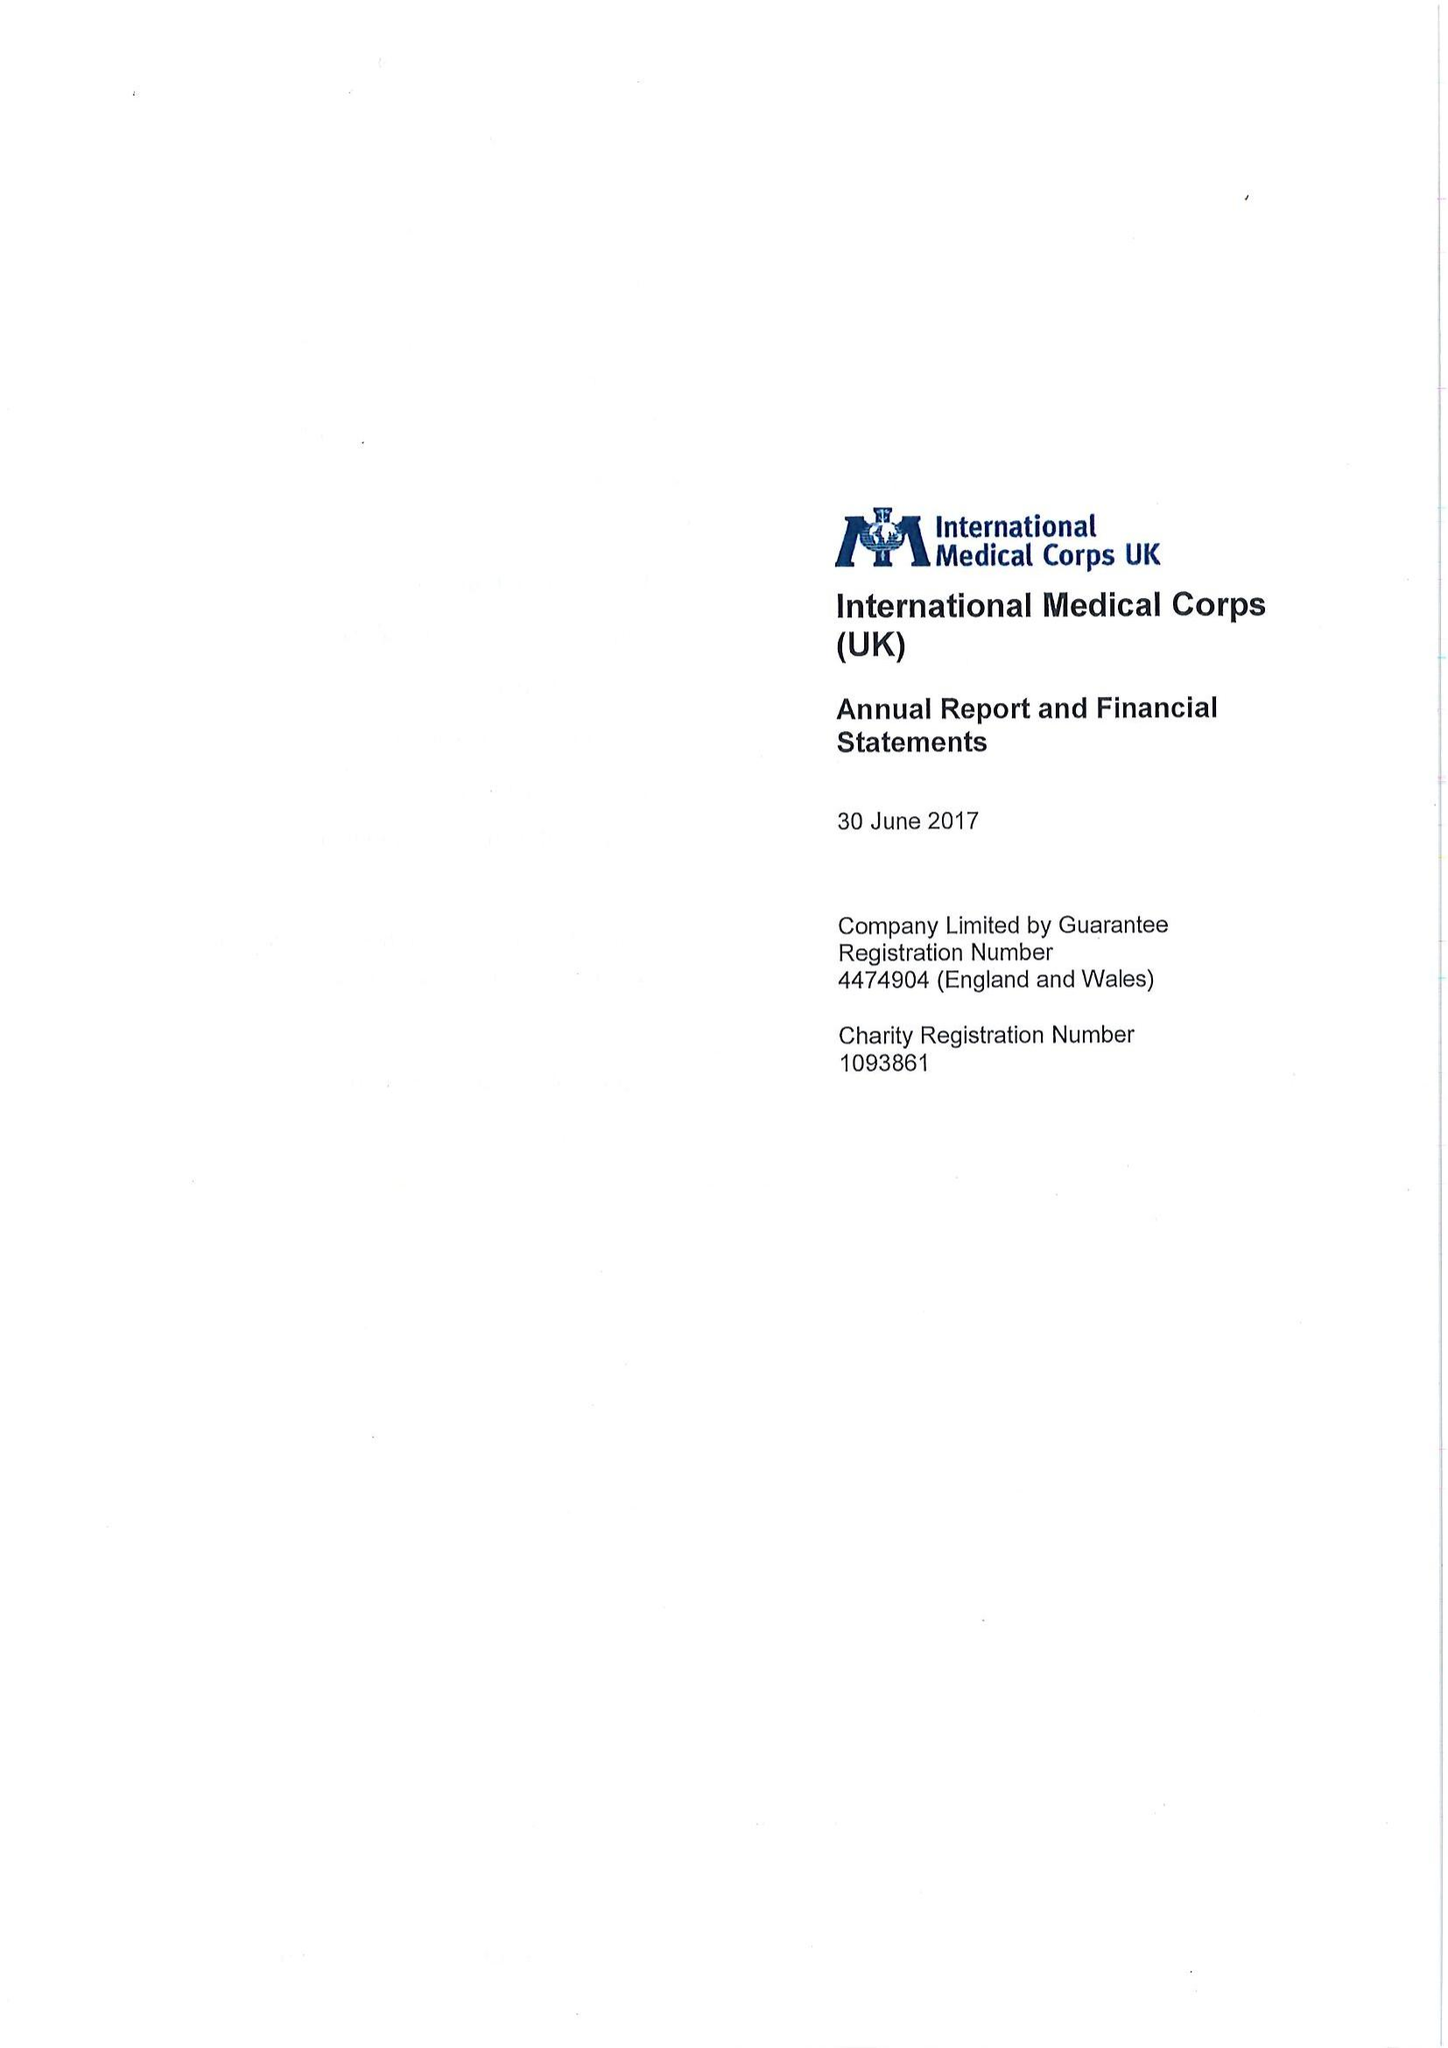What is the value for the report_date?
Answer the question using a single word or phrase. 2017-06-30 